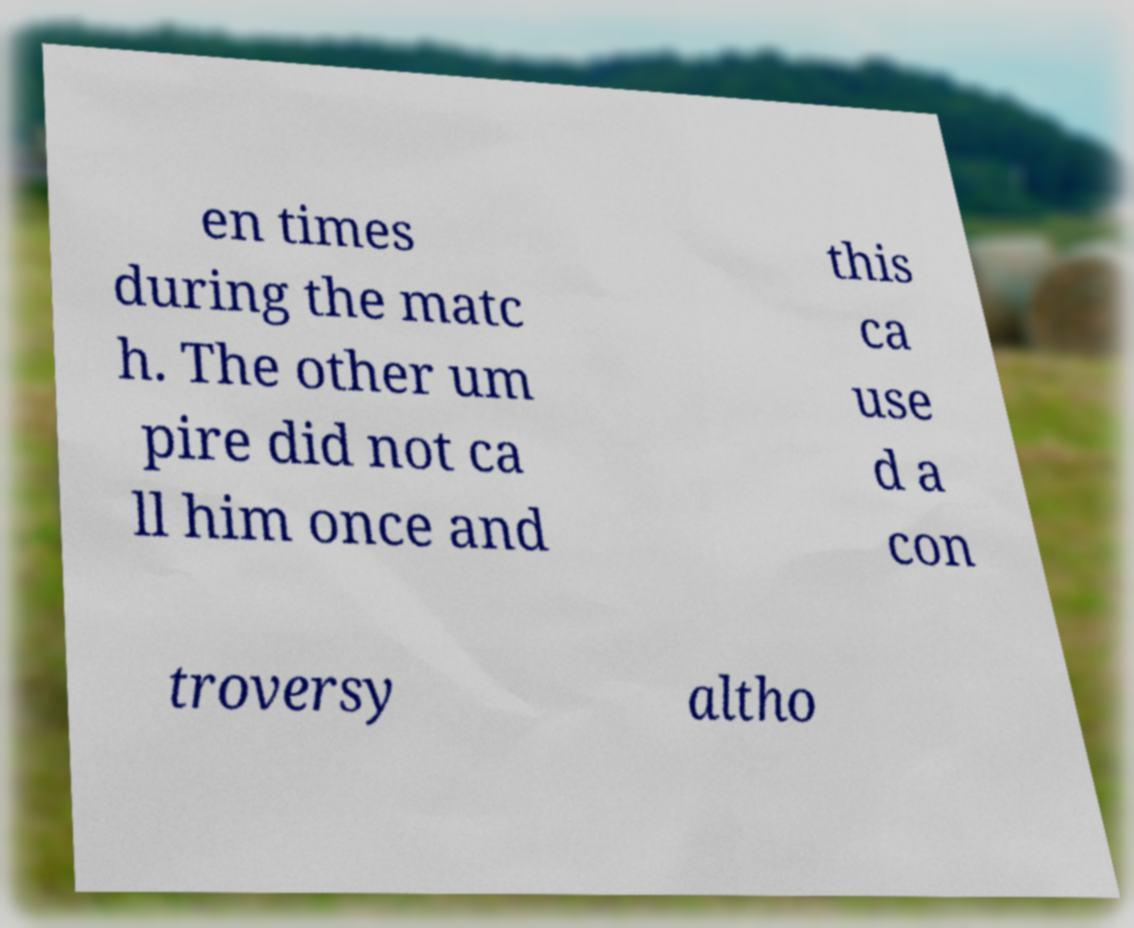Please identify and transcribe the text found in this image. en times during the matc h. The other um pire did not ca ll him once and this ca use d a con troversy altho 